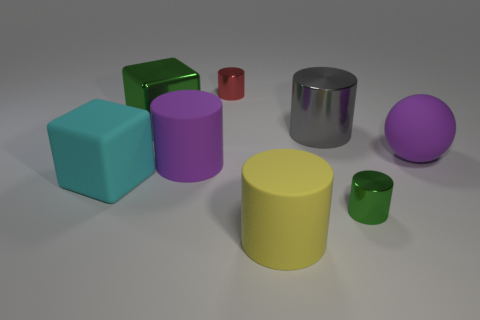What is the material of the object that is the same color as the large rubber sphere?
Give a very brief answer. Rubber. There is a tiny shiny object in front of the big rubber object on the right side of the green shiny cylinder; how many purple objects are on the left side of it?
Ensure brevity in your answer.  1. What is the size of the green metal cylinder?
Ensure brevity in your answer.  Small. What material is the purple cylinder that is the same size as the gray metallic cylinder?
Make the answer very short. Rubber. How many shiny cylinders are in front of the cyan matte object?
Provide a succinct answer. 1. Is the large purple object that is left of the gray metallic cylinder made of the same material as the tiny object on the left side of the yellow object?
Provide a succinct answer. No. The large cyan rubber object that is left of the thing that is on the right side of the green metal object in front of the large green metallic block is what shape?
Provide a short and direct response. Cube. The small green thing is what shape?
Your answer should be very brief. Cylinder. There is a green metal thing that is the same size as the cyan matte cube; what is its shape?
Offer a very short reply. Cube. What number of other objects are the same color as the big rubber sphere?
Make the answer very short. 1. 